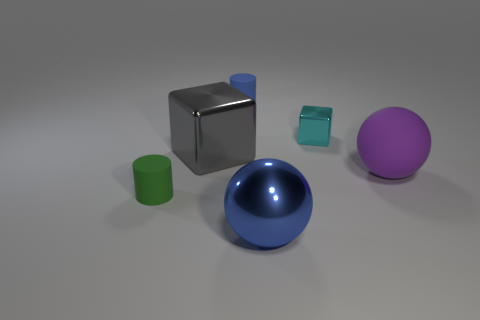How does the lighting in the image affect the appearance of the objects? The lighting in the image casts soft shadows and highlights, suggesting a diffused light source that's not too harsh. This gives the objects a three-dimensional appearance and accentuates their textures. The reflective properties of the objects, such as the shiny blue sphere and cube, show brighter highlights and clearer shadow boundaries, while the matte purple sphere has more subtle light variations due to its non-reflective surface. 